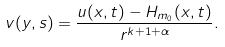Convert formula to latex. <formula><loc_0><loc_0><loc_500><loc_500>v ( y , s ) = \frac { u ( x , t ) - H _ { m _ { 0 } } ( x , t ) } { r ^ { k + 1 + \alpha } } .</formula> 